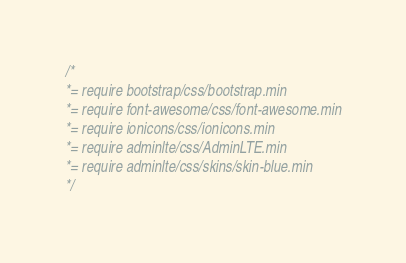<code> <loc_0><loc_0><loc_500><loc_500><_CSS_>/*
*= require bootstrap/css/bootstrap.min
*= require font-awesome/css/font-awesome.min
*= require ionicons/css/ionicons.min
*= require adminlte/css/AdminLTE.min
*= require adminlte/css/skins/skin-blue.min
*/
</code> 